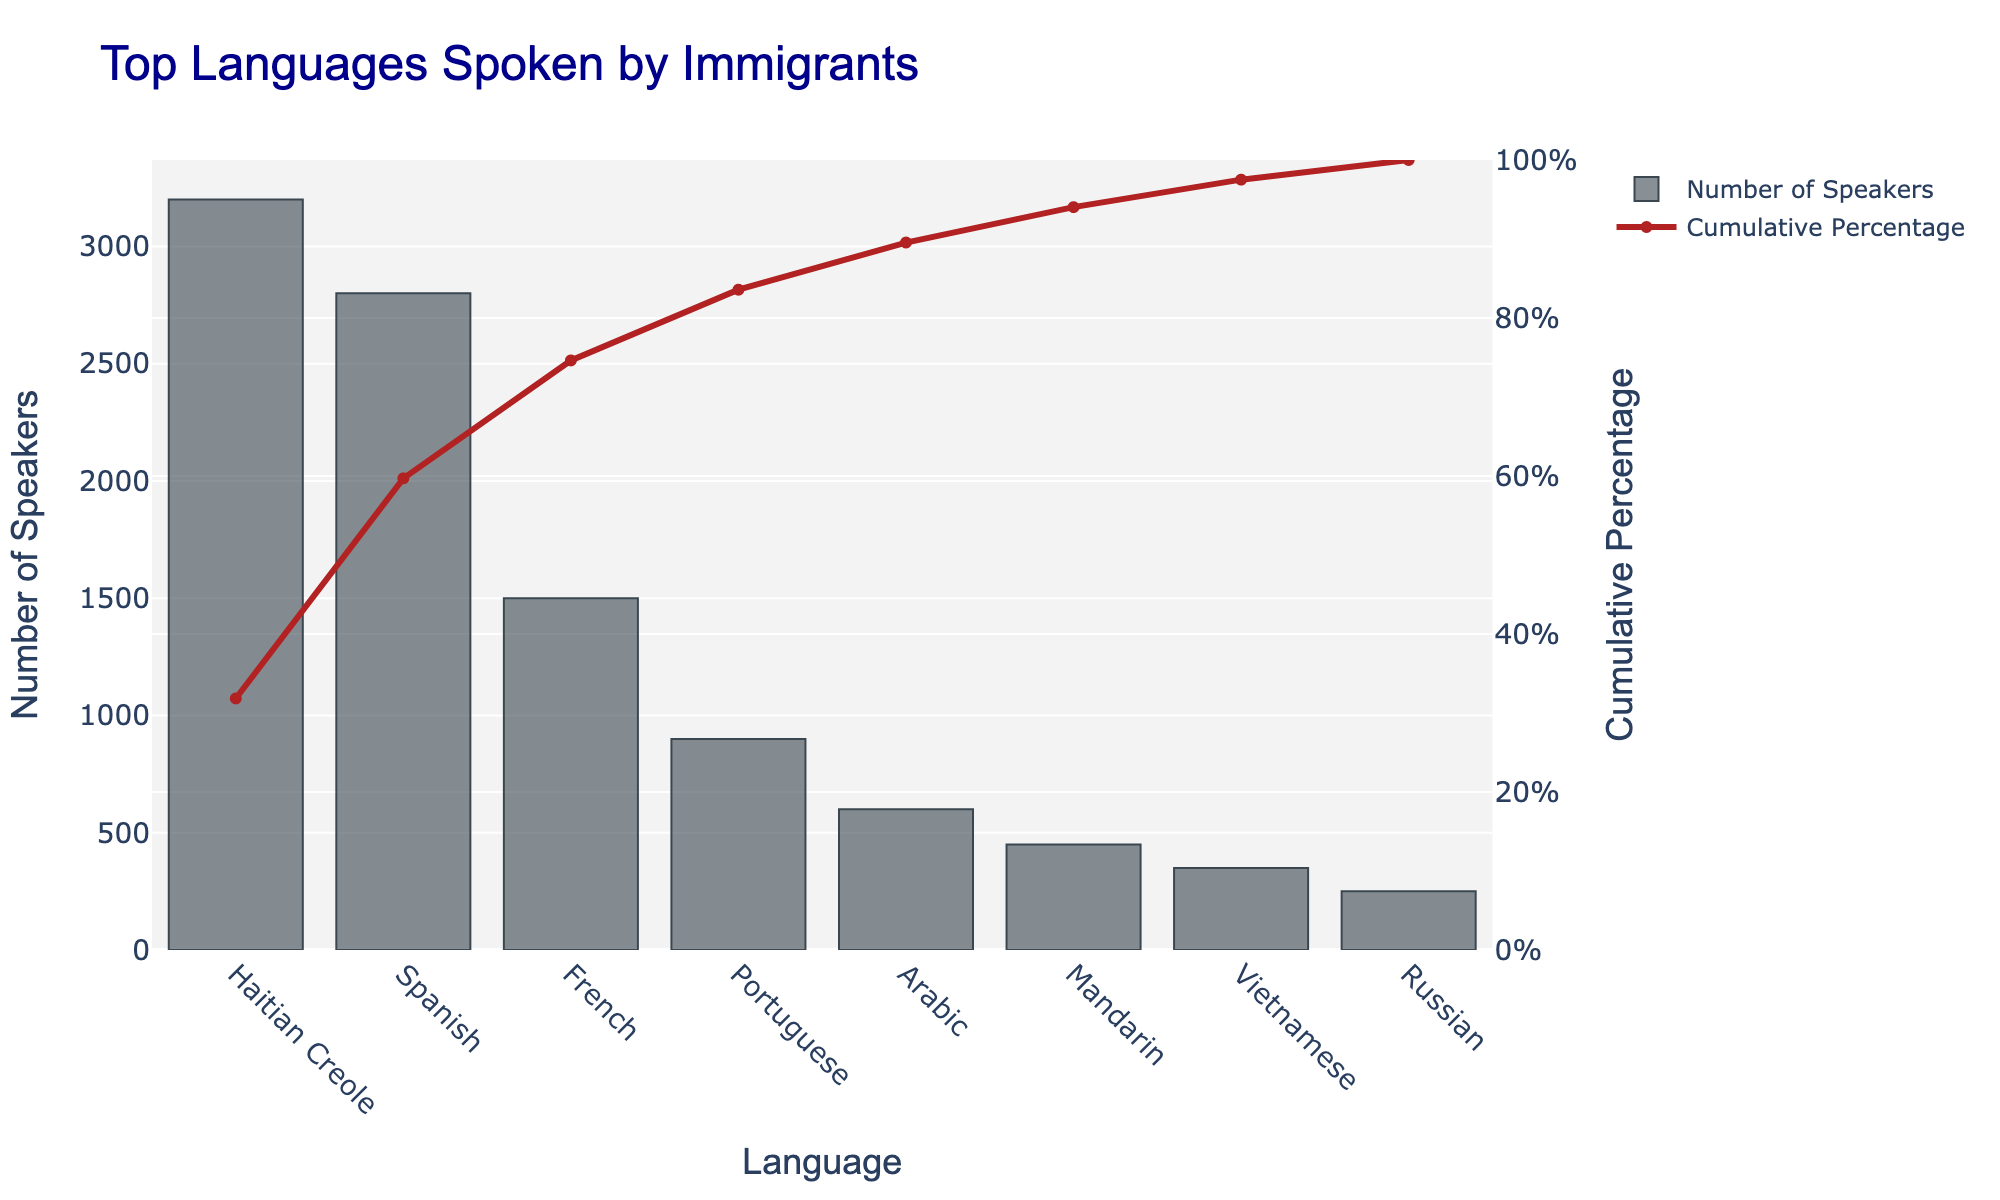What is the title of the chart? Look at the text at the top of the chart. The title reads "Top Languages Spoken by Immigrants".
Answer: Top Languages Spoken by Immigrants How many languages are listed in the chart? Count the bars in the bar chart. There are 8 different bars, each representing a language.
Answer: 8 Which language has the highest number of speakers? Identify the tallest bar in the bar chart. The tallest bar represents Haitian Creole.
Answer: Haitian Creole What is the cumulative percentage for Spanish? Find the red line corresponding to Spanish on the x-axis and see its value on the right y-axis. It's a bit above 60%.
Answer: A bit above 60% How many speakers speak Portuguese? Look at the bar corresponding to Portuguese and see the number indicated. Portuguese has 900 speakers.
Answer: 900 Which language has fewer speakers, Arabic or Mandarin? Compare the heights of the bars for Arabic and Mandarin. Mandarin has a shorter bar, meaning fewer speakers.
Answer: Mandarin What is the approximate cumulative percentage for Portuguese? Trace the red line for Portuguese on the x-axis, observing its value on the right y-axis. It's around 80%.
Answer: Around 80% What is the difference in the number of speakers between Haitian Creole and French? Subtract the number of speakers of French from Haitian Creole. 3200 - 1500 = 1700.
Answer: 1700 What is the cumulative percentage after Russian is included? Identify the cumulative percentage at the end of the series. It's 100% because Russian is the last language in the cumulative series.
Answer: 100% Which three languages collectively make up the highest cumulative percentage? Identify the red cumulative percentage line and see the three languages after which it reaches the highest value. They are Haitian Creole, Spanish, and French.
Answer: Haitian Creole, Spanish, and French 